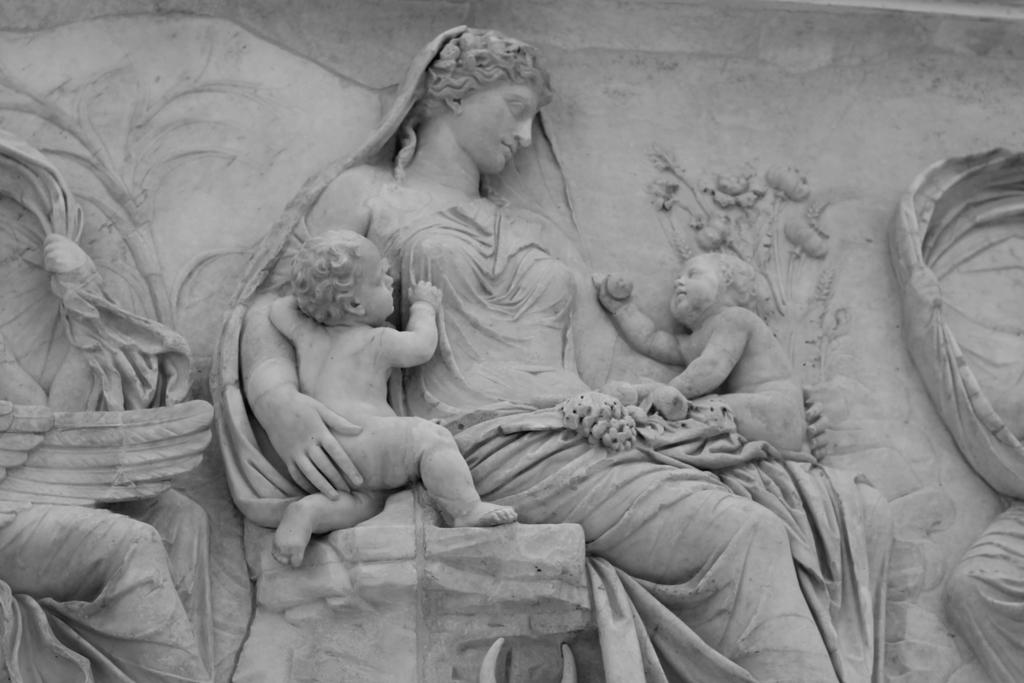What is the main subject of the image? There is a sculpture in the image. What type of sofa is depicted in the sculpture? There is no sofa present in the image, as it only features a sculpture. 